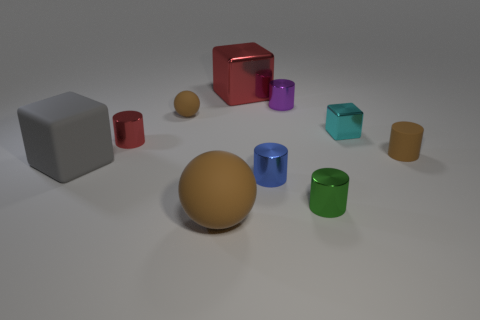Do the tiny brown thing that is to the right of the blue metallic cylinder and the big red object have the same material?
Provide a succinct answer. No. There is a brown object that is the same size as the brown cylinder; what is it made of?
Keep it short and to the point. Rubber. What number of other objects are there of the same material as the gray thing?
Ensure brevity in your answer.  3. Does the cyan cube have the same size as the brown ball behind the big gray rubber cube?
Your response must be concise. Yes. Is the number of tiny cyan rubber objects the same as the number of small brown matte balls?
Give a very brief answer. No. Is the number of metal cylinders behind the tiny metal cube less than the number of small brown matte cylinders that are behind the purple cylinder?
Give a very brief answer. No. There is a metallic object that is behind the tiny purple thing; how big is it?
Your answer should be compact. Large. Do the red shiny block and the matte cylinder have the same size?
Offer a terse response. No. What number of large objects are in front of the red cube and behind the green cylinder?
Your answer should be very brief. 1. What number of blue objects are either tiny rubber cylinders or tiny metal cubes?
Offer a terse response. 0. 